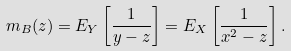<formula> <loc_0><loc_0><loc_500><loc_500>m _ { B } ( z ) = E _ { Y } \left [ \frac { 1 } { y - z } \right ] = E _ { X } \left [ \frac { 1 } { x ^ { 2 } - z } \right ] .</formula> 